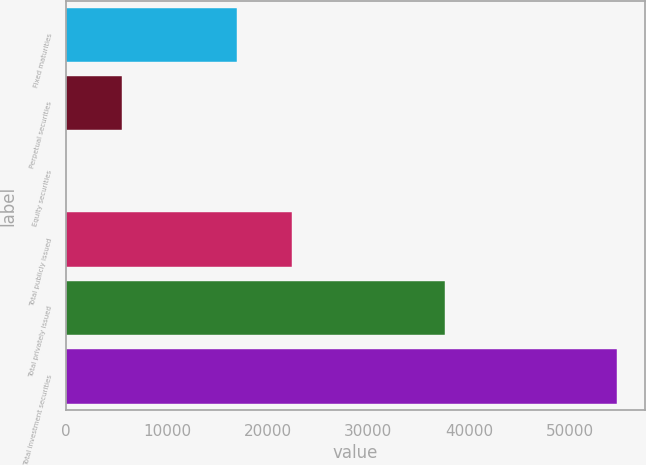<chart> <loc_0><loc_0><loc_500><loc_500><bar_chart><fcel>Fixed maturities<fcel>Perpetual securities<fcel>Equity securities<fcel>Total publicly issued<fcel>Total privately issued<fcel>Total investment securities<nl><fcel>16919<fcel>5492.4<fcel>19<fcel>22392.4<fcel>37658<fcel>54753<nl></chart> 